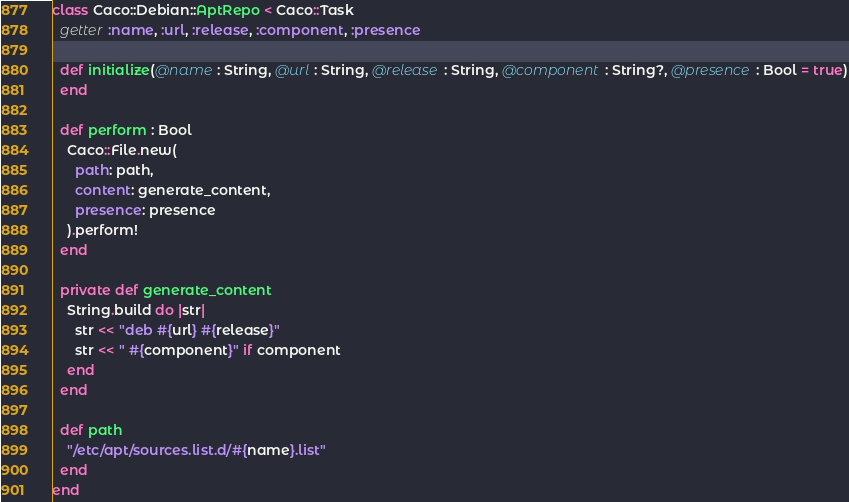Convert code to text. <code><loc_0><loc_0><loc_500><loc_500><_Crystal_>class Caco::Debian::AptRepo < Caco::Task
  getter :name, :url, :release, :component, :presence

  def initialize(@name : String, @url : String, @release : String, @component : String?, @presence : Bool = true)
  end

  def perform : Bool
    Caco::File.new(
      path: path,
      content: generate_content,
      presence: presence
    ).perform!
  end

  private def generate_content
    String.build do |str|
      str << "deb #{url} #{release}"
      str << " #{component}" if component
    end
  end

  def path
    "/etc/apt/sources.list.d/#{name}.list"
  end
end
</code> 